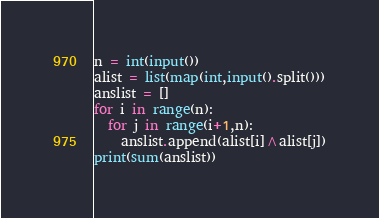<code> <loc_0><loc_0><loc_500><loc_500><_Python_>n = int(input())
alist = list(map(int,input().split()))
anslist = []
for i in range(n):
  for j in range(i+1,n):
    anslist.append(alist[i]^alist[j])
print(sum(anslist))</code> 